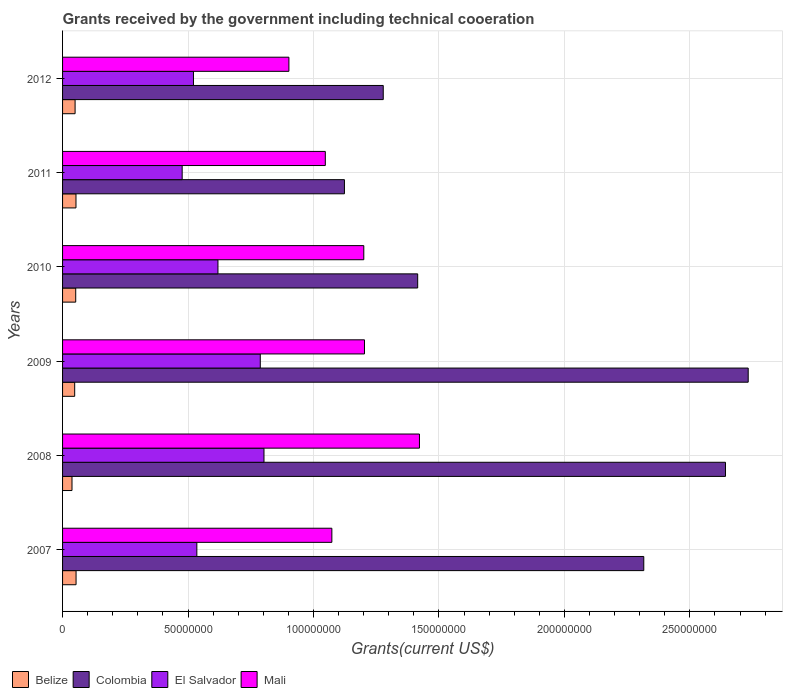How many groups of bars are there?
Your answer should be very brief. 6. Are the number of bars on each tick of the Y-axis equal?
Your answer should be compact. Yes. How many bars are there on the 3rd tick from the top?
Your answer should be very brief. 4. What is the label of the 6th group of bars from the top?
Ensure brevity in your answer.  2007. In how many cases, is the number of bars for a given year not equal to the number of legend labels?
Your answer should be compact. 0. What is the total grants received by the government in Mali in 2010?
Your answer should be very brief. 1.20e+08. Across all years, what is the maximum total grants received by the government in Mali?
Keep it short and to the point. 1.42e+08. Across all years, what is the minimum total grants received by the government in Colombia?
Make the answer very short. 1.12e+08. In which year was the total grants received by the government in Colombia minimum?
Keep it short and to the point. 2011. What is the total total grants received by the government in Mali in the graph?
Give a very brief answer. 6.85e+08. What is the difference between the total grants received by the government in Belize in 2008 and that in 2010?
Your answer should be very brief. -1.48e+06. What is the difference between the total grants received by the government in Mali in 2011 and the total grants received by the government in Colombia in 2007?
Provide a short and direct response. -1.27e+08. What is the average total grants received by the government in Colombia per year?
Provide a short and direct response. 1.92e+08. In the year 2007, what is the difference between the total grants received by the government in El Salvador and total grants received by the government in Colombia?
Give a very brief answer. -1.78e+08. What is the ratio of the total grants received by the government in El Salvador in 2008 to that in 2011?
Make the answer very short. 1.68. Is the difference between the total grants received by the government in El Salvador in 2009 and 2010 greater than the difference between the total grants received by the government in Colombia in 2009 and 2010?
Ensure brevity in your answer.  No. What is the difference between the highest and the lowest total grants received by the government in El Salvador?
Provide a short and direct response. 3.26e+07. Is it the case that in every year, the sum of the total grants received by the government in Belize and total grants received by the government in Mali is greater than the sum of total grants received by the government in Colombia and total grants received by the government in El Salvador?
Make the answer very short. No. What does the 4th bar from the top in 2010 represents?
Offer a very short reply. Belize. What does the 2nd bar from the bottom in 2008 represents?
Give a very brief answer. Colombia. How many bars are there?
Offer a terse response. 24. What is the difference between two consecutive major ticks on the X-axis?
Provide a succinct answer. 5.00e+07. Where does the legend appear in the graph?
Provide a succinct answer. Bottom left. What is the title of the graph?
Provide a short and direct response. Grants received by the government including technical cooeration. What is the label or title of the X-axis?
Provide a succinct answer. Grants(current US$). What is the label or title of the Y-axis?
Your answer should be very brief. Years. What is the Grants(current US$) of Belize in 2007?
Provide a succinct answer. 5.38e+06. What is the Grants(current US$) in Colombia in 2007?
Your response must be concise. 2.32e+08. What is the Grants(current US$) in El Salvador in 2007?
Make the answer very short. 5.35e+07. What is the Grants(current US$) of Mali in 2007?
Make the answer very short. 1.07e+08. What is the Grants(current US$) in Belize in 2008?
Give a very brief answer. 3.76e+06. What is the Grants(current US$) in Colombia in 2008?
Keep it short and to the point. 2.64e+08. What is the Grants(current US$) of El Salvador in 2008?
Make the answer very short. 8.03e+07. What is the Grants(current US$) in Mali in 2008?
Provide a succinct answer. 1.42e+08. What is the Grants(current US$) in Belize in 2009?
Provide a succinct answer. 4.83e+06. What is the Grants(current US$) in Colombia in 2009?
Provide a succinct answer. 2.73e+08. What is the Grants(current US$) in El Salvador in 2009?
Ensure brevity in your answer.  7.88e+07. What is the Grants(current US$) of Mali in 2009?
Offer a very short reply. 1.20e+08. What is the Grants(current US$) of Belize in 2010?
Make the answer very short. 5.24e+06. What is the Grants(current US$) in Colombia in 2010?
Provide a succinct answer. 1.42e+08. What is the Grants(current US$) of El Salvador in 2010?
Your answer should be compact. 6.19e+07. What is the Grants(current US$) in Mali in 2010?
Provide a short and direct response. 1.20e+08. What is the Grants(current US$) of Belize in 2011?
Give a very brief answer. 5.35e+06. What is the Grants(current US$) of Colombia in 2011?
Make the answer very short. 1.12e+08. What is the Grants(current US$) of El Salvador in 2011?
Your response must be concise. 4.77e+07. What is the Grants(current US$) in Mali in 2011?
Offer a terse response. 1.05e+08. What is the Grants(current US$) in Belize in 2012?
Give a very brief answer. 4.99e+06. What is the Grants(current US$) of Colombia in 2012?
Provide a short and direct response. 1.28e+08. What is the Grants(current US$) of El Salvador in 2012?
Your answer should be very brief. 5.22e+07. What is the Grants(current US$) in Mali in 2012?
Provide a succinct answer. 9.02e+07. Across all years, what is the maximum Grants(current US$) of Belize?
Offer a very short reply. 5.38e+06. Across all years, what is the maximum Grants(current US$) of Colombia?
Make the answer very short. 2.73e+08. Across all years, what is the maximum Grants(current US$) of El Salvador?
Your response must be concise. 8.03e+07. Across all years, what is the maximum Grants(current US$) of Mali?
Your answer should be compact. 1.42e+08. Across all years, what is the minimum Grants(current US$) in Belize?
Offer a terse response. 3.76e+06. Across all years, what is the minimum Grants(current US$) of Colombia?
Give a very brief answer. 1.12e+08. Across all years, what is the minimum Grants(current US$) in El Salvador?
Offer a very short reply. 4.77e+07. Across all years, what is the minimum Grants(current US$) in Mali?
Provide a succinct answer. 9.02e+07. What is the total Grants(current US$) in Belize in the graph?
Give a very brief answer. 2.96e+07. What is the total Grants(current US$) of Colombia in the graph?
Provide a succinct answer. 1.15e+09. What is the total Grants(current US$) in El Salvador in the graph?
Your answer should be compact. 3.74e+08. What is the total Grants(current US$) of Mali in the graph?
Provide a succinct answer. 6.85e+08. What is the difference between the Grants(current US$) in Belize in 2007 and that in 2008?
Give a very brief answer. 1.62e+06. What is the difference between the Grants(current US$) of Colombia in 2007 and that in 2008?
Offer a terse response. -3.26e+07. What is the difference between the Grants(current US$) in El Salvador in 2007 and that in 2008?
Offer a very short reply. -2.68e+07. What is the difference between the Grants(current US$) of Mali in 2007 and that in 2008?
Offer a terse response. -3.49e+07. What is the difference between the Grants(current US$) in Belize in 2007 and that in 2009?
Your answer should be very brief. 5.50e+05. What is the difference between the Grants(current US$) in Colombia in 2007 and that in 2009?
Your answer should be compact. -4.16e+07. What is the difference between the Grants(current US$) of El Salvador in 2007 and that in 2009?
Your response must be concise. -2.53e+07. What is the difference between the Grants(current US$) in Mali in 2007 and that in 2009?
Keep it short and to the point. -1.30e+07. What is the difference between the Grants(current US$) in Belize in 2007 and that in 2010?
Offer a terse response. 1.40e+05. What is the difference between the Grants(current US$) of Colombia in 2007 and that in 2010?
Offer a very short reply. 9.01e+07. What is the difference between the Grants(current US$) in El Salvador in 2007 and that in 2010?
Your answer should be very brief. -8.41e+06. What is the difference between the Grants(current US$) in Mali in 2007 and that in 2010?
Offer a terse response. -1.27e+07. What is the difference between the Grants(current US$) of Belize in 2007 and that in 2011?
Offer a terse response. 3.00e+04. What is the difference between the Grants(current US$) in Colombia in 2007 and that in 2011?
Your answer should be compact. 1.19e+08. What is the difference between the Grants(current US$) in El Salvador in 2007 and that in 2011?
Your answer should be compact. 5.85e+06. What is the difference between the Grants(current US$) in Mali in 2007 and that in 2011?
Keep it short and to the point. 2.61e+06. What is the difference between the Grants(current US$) of Belize in 2007 and that in 2012?
Provide a succinct answer. 3.90e+05. What is the difference between the Grants(current US$) in Colombia in 2007 and that in 2012?
Offer a very short reply. 1.04e+08. What is the difference between the Grants(current US$) of El Salvador in 2007 and that in 2012?
Provide a short and direct response. 1.35e+06. What is the difference between the Grants(current US$) in Mali in 2007 and that in 2012?
Your response must be concise. 1.71e+07. What is the difference between the Grants(current US$) in Belize in 2008 and that in 2009?
Offer a terse response. -1.07e+06. What is the difference between the Grants(current US$) of Colombia in 2008 and that in 2009?
Ensure brevity in your answer.  -9.06e+06. What is the difference between the Grants(current US$) of El Salvador in 2008 and that in 2009?
Offer a terse response. 1.48e+06. What is the difference between the Grants(current US$) in Mali in 2008 and that in 2009?
Your answer should be compact. 2.19e+07. What is the difference between the Grants(current US$) of Belize in 2008 and that in 2010?
Your answer should be very brief. -1.48e+06. What is the difference between the Grants(current US$) in Colombia in 2008 and that in 2010?
Your answer should be very brief. 1.23e+08. What is the difference between the Grants(current US$) of El Salvador in 2008 and that in 2010?
Make the answer very short. 1.84e+07. What is the difference between the Grants(current US$) in Mali in 2008 and that in 2010?
Ensure brevity in your answer.  2.22e+07. What is the difference between the Grants(current US$) in Belize in 2008 and that in 2011?
Offer a terse response. -1.59e+06. What is the difference between the Grants(current US$) in Colombia in 2008 and that in 2011?
Your response must be concise. 1.52e+08. What is the difference between the Grants(current US$) of El Salvador in 2008 and that in 2011?
Make the answer very short. 3.26e+07. What is the difference between the Grants(current US$) of Mali in 2008 and that in 2011?
Give a very brief answer. 3.75e+07. What is the difference between the Grants(current US$) in Belize in 2008 and that in 2012?
Offer a terse response. -1.23e+06. What is the difference between the Grants(current US$) of Colombia in 2008 and that in 2012?
Your answer should be compact. 1.36e+08. What is the difference between the Grants(current US$) in El Salvador in 2008 and that in 2012?
Your answer should be very brief. 2.81e+07. What is the difference between the Grants(current US$) of Mali in 2008 and that in 2012?
Keep it short and to the point. 5.20e+07. What is the difference between the Grants(current US$) in Belize in 2009 and that in 2010?
Keep it short and to the point. -4.10e+05. What is the difference between the Grants(current US$) of Colombia in 2009 and that in 2010?
Keep it short and to the point. 1.32e+08. What is the difference between the Grants(current US$) of El Salvador in 2009 and that in 2010?
Provide a short and direct response. 1.69e+07. What is the difference between the Grants(current US$) of Mali in 2009 and that in 2010?
Provide a short and direct response. 2.70e+05. What is the difference between the Grants(current US$) of Belize in 2009 and that in 2011?
Provide a short and direct response. -5.20e+05. What is the difference between the Grants(current US$) in Colombia in 2009 and that in 2011?
Provide a succinct answer. 1.61e+08. What is the difference between the Grants(current US$) of El Salvador in 2009 and that in 2011?
Offer a terse response. 3.11e+07. What is the difference between the Grants(current US$) of Mali in 2009 and that in 2011?
Make the answer very short. 1.56e+07. What is the difference between the Grants(current US$) of Colombia in 2009 and that in 2012?
Keep it short and to the point. 1.45e+08. What is the difference between the Grants(current US$) of El Salvador in 2009 and that in 2012?
Ensure brevity in your answer.  2.66e+07. What is the difference between the Grants(current US$) of Mali in 2009 and that in 2012?
Your answer should be compact. 3.01e+07. What is the difference between the Grants(current US$) of Belize in 2010 and that in 2011?
Provide a succinct answer. -1.10e+05. What is the difference between the Grants(current US$) of Colombia in 2010 and that in 2011?
Make the answer very short. 2.92e+07. What is the difference between the Grants(current US$) in El Salvador in 2010 and that in 2011?
Provide a succinct answer. 1.43e+07. What is the difference between the Grants(current US$) in Mali in 2010 and that in 2011?
Keep it short and to the point. 1.53e+07. What is the difference between the Grants(current US$) in Colombia in 2010 and that in 2012?
Provide a succinct answer. 1.37e+07. What is the difference between the Grants(current US$) in El Salvador in 2010 and that in 2012?
Offer a very short reply. 9.76e+06. What is the difference between the Grants(current US$) of Mali in 2010 and that in 2012?
Your response must be concise. 2.98e+07. What is the difference between the Grants(current US$) in Colombia in 2011 and that in 2012?
Make the answer very short. -1.55e+07. What is the difference between the Grants(current US$) of El Salvador in 2011 and that in 2012?
Offer a very short reply. -4.50e+06. What is the difference between the Grants(current US$) of Mali in 2011 and that in 2012?
Provide a short and direct response. 1.45e+07. What is the difference between the Grants(current US$) of Belize in 2007 and the Grants(current US$) of Colombia in 2008?
Your answer should be compact. -2.59e+08. What is the difference between the Grants(current US$) in Belize in 2007 and the Grants(current US$) in El Salvador in 2008?
Your answer should be very brief. -7.49e+07. What is the difference between the Grants(current US$) of Belize in 2007 and the Grants(current US$) of Mali in 2008?
Your response must be concise. -1.37e+08. What is the difference between the Grants(current US$) of Colombia in 2007 and the Grants(current US$) of El Salvador in 2008?
Give a very brief answer. 1.51e+08. What is the difference between the Grants(current US$) of Colombia in 2007 and the Grants(current US$) of Mali in 2008?
Your response must be concise. 8.94e+07. What is the difference between the Grants(current US$) of El Salvador in 2007 and the Grants(current US$) of Mali in 2008?
Your answer should be compact. -8.87e+07. What is the difference between the Grants(current US$) of Belize in 2007 and the Grants(current US$) of Colombia in 2009?
Offer a very short reply. -2.68e+08. What is the difference between the Grants(current US$) in Belize in 2007 and the Grants(current US$) in El Salvador in 2009?
Give a very brief answer. -7.34e+07. What is the difference between the Grants(current US$) of Belize in 2007 and the Grants(current US$) of Mali in 2009?
Your response must be concise. -1.15e+08. What is the difference between the Grants(current US$) of Colombia in 2007 and the Grants(current US$) of El Salvador in 2009?
Your answer should be very brief. 1.53e+08. What is the difference between the Grants(current US$) of Colombia in 2007 and the Grants(current US$) of Mali in 2009?
Give a very brief answer. 1.11e+08. What is the difference between the Grants(current US$) of El Salvador in 2007 and the Grants(current US$) of Mali in 2009?
Ensure brevity in your answer.  -6.68e+07. What is the difference between the Grants(current US$) of Belize in 2007 and the Grants(current US$) of Colombia in 2010?
Your answer should be compact. -1.36e+08. What is the difference between the Grants(current US$) in Belize in 2007 and the Grants(current US$) in El Salvador in 2010?
Offer a very short reply. -5.66e+07. What is the difference between the Grants(current US$) in Belize in 2007 and the Grants(current US$) in Mali in 2010?
Your response must be concise. -1.15e+08. What is the difference between the Grants(current US$) of Colombia in 2007 and the Grants(current US$) of El Salvador in 2010?
Give a very brief answer. 1.70e+08. What is the difference between the Grants(current US$) in Colombia in 2007 and the Grants(current US$) in Mali in 2010?
Your answer should be very brief. 1.12e+08. What is the difference between the Grants(current US$) in El Salvador in 2007 and the Grants(current US$) in Mali in 2010?
Make the answer very short. -6.65e+07. What is the difference between the Grants(current US$) of Belize in 2007 and the Grants(current US$) of Colombia in 2011?
Offer a very short reply. -1.07e+08. What is the difference between the Grants(current US$) in Belize in 2007 and the Grants(current US$) in El Salvador in 2011?
Give a very brief answer. -4.23e+07. What is the difference between the Grants(current US$) of Belize in 2007 and the Grants(current US$) of Mali in 2011?
Give a very brief answer. -9.93e+07. What is the difference between the Grants(current US$) in Colombia in 2007 and the Grants(current US$) in El Salvador in 2011?
Your answer should be compact. 1.84e+08. What is the difference between the Grants(current US$) of Colombia in 2007 and the Grants(current US$) of Mali in 2011?
Offer a terse response. 1.27e+08. What is the difference between the Grants(current US$) of El Salvador in 2007 and the Grants(current US$) of Mali in 2011?
Your answer should be very brief. -5.12e+07. What is the difference between the Grants(current US$) of Belize in 2007 and the Grants(current US$) of Colombia in 2012?
Your answer should be very brief. -1.22e+08. What is the difference between the Grants(current US$) in Belize in 2007 and the Grants(current US$) in El Salvador in 2012?
Make the answer very short. -4.68e+07. What is the difference between the Grants(current US$) of Belize in 2007 and the Grants(current US$) of Mali in 2012?
Keep it short and to the point. -8.48e+07. What is the difference between the Grants(current US$) of Colombia in 2007 and the Grants(current US$) of El Salvador in 2012?
Make the answer very short. 1.79e+08. What is the difference between the Grants(current US$) of Colombia in 2007 and the Grants(current US$) of Mali in 2012?
Ensure brevity in your answer.  1.41e+08. What is the difference between the Grants(current US$) of El Salvador in 2007 and the Grants(current US$) of Mali in 2012?
Give a very brief answer. -3.67e+07. What is the difference between the Grants(current US$) of Belize in 2008 and the Grants(current US$) of Colombia in 2009?
Provide a succinct answer. -2.70e+08. What is the difference between the Grants(current US$) of Belize in 2008 and the Grants(current US$) of El Salvador in 2009?
Keep it short and to the point. -7.50e+07. What is the difference between the Grants(current US$) in Belize in 2008 and the Grants(current US$) in Mali in 2009?
Make the answer very short. -1.17e+08. What is the difference between the Grants(current US$) of Colombia in 2008 and the Grants(current US$) of El Salvador in 2009?
Your answer should be very brief. 1.85e+08. What is the difference between the Grants(current US$) in Colombia in 2008 and the Grants(current US$) in Mali in 2009?
Offer a very short reply. 1.44e+08. What is the difference between the Grants(current US$) of El Salvador in 2008 and the Grants(current US$) of Mali in 2009?
Offer a very short reply. -4.00e+07. What is the difference between the Grants(current US$) of Belize in 2008 and the Grants(current US$) of Colombia in 2010?
Your answer should be compact. -1.38e+08. What is the difference between the Grants(current US$) of Belize in 2008 and the Grants(current US$) of El Salvador in 2010?
Provide a short and direct response. -5.82e+07. What is the difference between the Grants(current US$) of Belize in 2008 and the Grants(current US$) of Mali in 2010?
Keep it short and to the point. -1.16e+08. What is the difference between the Grants(current US$) in Colombia in 2008 and the Grants(current US$) in El Salvador in 2010?
Ensure brevity in your answer.  2.02e+08. What is the difference between the Grants(current US$) of Colombia in 2008 and the Grants(current US$) of Mali in 2010?
Make the answer very short. 1.44e+08. What is the difference between the Grants(current US$) in El Salvador in 2008 and the Grants(current US$) in Mali in 2010?
Provide a succinct answer. -3.98e+07. What is the difference between the Grants(current US$) in Belize in 2008 and the Grants(current US$) in Colombia in 2011?
Offer a terse response. -1.09e+08. What is the difference between the Grants(current US$) of Belize in 2008 and the Grants(current US$) of El Salvador in 2011?
Give a very brief answer. -4.39e+07. What is the difference between the Grants(current US$) of Belize in 2008 and the Grants(current US$) of Mali in 2011?
Your answer should be compact. -1.01e+08. What is the difference between the Grants(current US$) in Colombia in 2008 and the Grants(current US$) in El Salvador in 2011?
Ensure brevity in your answer.  2.17e+08. What is the difference between the Grants(current US$) in Colombia in 2008 and the Grants(current US$) in Mali in 2011?
Offer a very short reply. 1.59e+08. What is the difference between the Grants(current US$) in El Salvador in 2008 and the Grants(current US$) in Mali in 2011?
Give a very brief answer. -2.44e+07. What is the difference between the Grants(current US$) of Belize in 2008 and the Grants(current US$) of Colombia in 2012?
Your response must be concise. -1.24e+08. What is the difference between the Grants(current US$) in Belize in 2008 and the Grants(current US$) in El Salvador in 2012?
Make the answer very short. -4.84e+07. What is the difference between the Grants(current US$) of Belize in 2008 and the Grants(current US$) of Mali in 2012?
Make the answer very short. -8.64e+07. What is the difference between the Grants(current US$) in Colombia in 2008 and the Grants(current US$) in El Salvador in 2012?
Offer a very short reply. 2.12e+08. What is the difference between the Grants(current US$) of Colombia in 2008 and the Grants(current US$) of Mali in 2012?
Provide a short and direct response. 1.74e+08. What is the difference between the Grants(current US$) of El Salvador in 2008 and the Grants(current US$) of Mali in 2012?
Your answer should be compact. -9.93e+06. What is the difference between the Grants(current US$) in Belize in 2009 and the Grants(current US$) in Colombia in 2010?
Your response must be concise. -1.37e+08. What is the difference between the Grants(current US$) of Belize in 2009 and the Grants(current US$) of El Salvador in 2010?
Provide a succinct answer. -5.71e+07. What is the difference between the Grants(current US$) in Belize in 2009 and the Grants(current US$) in Mali in 2010?
Ensure brevity in your answer.  -1.15e+08. What is the difference between the Grants(current US$) in Colombia in 2009 and the Grants(current US$) in El Salvador in 2010?
Keep it short and to the point. 2.11e+08. What is the difference between the Grants(current US$) of Colombia in 2009 and the Grants(current US$) of Mali in 2010?
Ensure brevity in your answer.  1.53e+08. What is the difference between the Grants(current US$) of El Salvador in 2009 and the Grants(current US$) of Mali in 2010?
Provide a short and direct response. -4.13e+07. What is the difference between the Grants(current US$) of Belize in 2009 and the Grants(current US$) of Colombia in 2011?
Offer a terse response. -1.08e+08. What is the difference between the Grants(current US$) in Belize in 2009 and the Grants(current US$) in El Salvador in 2011?
Keep it short and to the point. -4.28e+07. What is the difference between the Grants(current US$) in Belize in 2009 and the Grants(current US$) in Mali in 2011?
Offer a terse response. -9.99e+07. What is the difference between the Grants(current US$) of Colombia in 2009 and the Grants(current US$) of El Salvador in 2011?
Your response must be concise. 2.26e+08. What is the difference between the Grants(current US$) of Colombia in 2009 and the Grants(current US$) of Mali in 2011?
Your answer should be very brief. 1.69e+08. What is the difference between the Grants(current US$) in El Salvador in 2009 and the Grants(current US$) in Mali in 2011?
Give a very brief answer. -2.59e+07. What is the difference between the Grants(current US$) in Belize in 2009 and the Grants(current US$) in Colombia in 2012?
Give a very brief answer. -1.23e+08. What is the difference between the Grants(current US$) of Belize in 2009 and the Grants(current US$) of El Salvador in 2012?
Provide a short and direct response. -4.73e+07. What is the difference between the Grants(current US$) in Belize in 2009 and the Grants(current US$) in Mali in 2012?
Give a very brief answer. -8.54e+07. What is the difference between the Grants(current US$) of Colombia in 2009 and the Grants(current US$) of El Salvador in 2012?
Your answer should be compact. 2.21e+08. What is the difference between the Grants(current US$) in Colombia in 2009 and the Grants(current US$) in Mali in 2012?
Offer a terse response. 1.83e+08. What is the difference between the Grants(current US$) of El Salvador in 2009 and the Grants(current US$) of Mali in 2012?
Your answer should be very brief. -1.14e+07. What is the difference between the Grants(current US$) of Belize in 2010 and the Grants(current US$) of Colombia in 2011?
Offer a terse response. -1.07e+08. What is the difference between the Grants(current US$) of Belize in 2010 and the Grants(current US$) of El Salvador in 2011?
Keep it short and to the point. -4.24e+07. What is the difference between the Grants(current US$) in Belize in 2010 and the Grants(current US$) in Mali in 2011?
Provide a succinct answer. -9.95e+07. What is the difference between the Grants(current US$) in Colombia in 2010 and the Grants(current US$) in El Salvador in 2011?
Give a very brief answer. 9.39e+07. What is the difference between the Grants(current US$) of Colombia in 2010 and the Grants(current US$) of Mali in 2011?
Keep it short and to the point. 3.68e+07. What is the difference between the Grants(current US$) in El Salvador in 2010 and the Grants(current US$) in Mali in 2011?
Provide a succinct answer. -4.28e+07. What is the difference between the Grants(current US$) of Belize in 2010 and the Grants(current US$) of Colombia in 2012?
Offer a terse response. -1.23e+08. What is the difference between the Grants(current US$) of Belize in 2010 and the Grants(current US$) of El Salvador in 2012?
Offer a terse response. -4.69e+07. What is the difference between the Grants(current US$) of Belize in 2010 and the Grants(current US$) of Mali in 2012?
Offer a very short reply. -8.50e+07. What is the difference between the Grants(current US$) of Colombia in 2010 and the Grants(current US$) of El Salvador in 2012?
Provide a succinct answer. 8.94e+07. What is the difference between the Grants(current US$) of Colombia in 2010 and the Grants(current US$) of Mali in 2012?
Your response must be concise. 5.13e+07. What is the difference between the Grants(current US$) of El Salvador in 2010 and the Grants(current US$) of Mali in 2012?
Offer a very short reply. -2.83e+07. What is the difference between the Grants(current US$) in Belize in 2011 and the Grants(current US$) in Colombia in 2012?
Provide a short and direct response. -1.22e+08. What is the difference between the Grants(current US$) in Belize in 2011 and the Grants(current US$) in El Salvador in 2012?
Your answer should be very brief. -4.68e+07. What is the difference between the Grants(current US$) of Belize in 2011 and the Grants(current US$) of Mali in 2012?
Keep it short and to the point. -8.49e+07. What is the difference between the Grants(current US$) in Colombia in 2011 and the Grants(current US$) in El Salvador in 2012?
Keep it short and to the point. 6.02e+07. What is the difference between the Grants(current US$) in Colombia in 2011 and the Grants(current US$) in Mali in 2012?
Your answer should be compact. 2.21e+07. What is the difference between the Grants(current US$) in El Salvador in 2011 and the Grants(current US$) in Mali in 2012?
Offer a very short reply. -4.25e+07. What is the average Grants(current US$) of Belize per year?
Offer a terse response. 4.92e+06. What is the average Grants(current US$) in Colombia per year?
Ensure brevity in your answer.  1.92e+08. What is the average Grants(current US$) in El Salvador per year?
Provide a short and direct response. 6.24e+07. What is the average Grants(current US$) in Mali per year?
Provide a succinct answer. 1.14e+08. In the year 2007, what is the difference between the Grants(current US$) in Belize and Grants(current US$) in Colombia?
Provide a short and direct response. -2.26e+08. In the year 2007, what is the difference between the Grants(current US$) in Belize and Grants(current US$) in El Salvador?
Your answer should be compact. -4.81e+07. In the year 2007, what is the difference between the Grants(current US$) of Belize and Grants(current US$) of Mali?
Keep it short and to the point. -1.02e+08. In the year 2007, what is the difference between the Grants(current US$) of Colombia and Grants(current US$) of El Salvador?
Give a very brief answer. 1.78e+08. In the year 2007, what is the difference between the Grants(current US$) in Colombia and Grants(current US$) in Mali?
Make the answer very short. 1.24e+08. In the year 2007, what is the difference between the Grants(current US$) of El Salvador and Grants(current US$) of Mali?
Your answer should be very brief. -5.38e+07. In the year 2008, what is the difference between the Grants(current US$) in Belize and Grants(current US$) in Colombia?
Keep it short and to the point. -2.60e+08. In the year 2008, what is the difference between the Grants(current US$) in Belize and Grants(current US$) in El Salvador?
Offer a very short reply. -7.65e+07. In the year 2008, what is the difference between the Grants(current US$) in Belize and Grants(current US$) in Mali?
Offer a terse response. -1.38e+08. In the year 2008, what is the difference between the Grants(current US$) in Colombia and Grants(current US$) in El Salvador?
Your answer should be compact. 1.84e+08. In the year 2008, what is the difference between the Grants(current US$) of Colombia and Grants(current US$) of Mali?
Your response must be concise. 1.22e+08. In the year 2008, what is the difference between the Grants(current US$) in El Salvador and Grants(current US$) in Mali?
Your response must be concise. -6.20e+07. In the year 2009, what is the difference between the Grants(current US$) in Belize and Grants(current US$) in Colombia?
Give a very brief answer. -2.68e+08. In the year 2009, what is the difference between the Grants(current US$) in Belize and Grants(current US$) in El Salvador?
Offer a terse response. -7.40e+07. In the year 2009, what is the difference between the Grants(current US$) of Belize and Grants(current US$) of Mali?
Your response must be concise. -1.16e+08. In the year 2009, what is the difference between the Grants(current US$) in Colombia and Grants(current US$) in El Salvador?
Ensure brevity in your answer.  1.94e+08. In the year 2009, what is the difference between the Grants(current US$) of Colombia and Grants(current US$) of Mali?
Offer a terse response. 1.53e+08. In the year 2009, what is the difference between the Grants(current US$) in El Salvador and Grants(current US$) in Mali?
Provide a succinct answer. -4.15e+07. In the year 2010, what is the difference between the Grants(current US$) in Belize and Grants(current US$) in Colombia?
Give a very brief answer. -1.36e+08. In the year 2010, what is the difference between the Grants(current US$) in Belize and Grants(current US$) in El Salvador?
Offer a very short reply. -5.67e+07. In the year 2010, what is the difference between the Grants(current US$) of Belize and Grants(current US$) of Mali?
Your answer should be compact. -1.15e+08. In the year 2010, what is the difference between the Grants(current US$) of Colombia and Grants(current US$) of El Salvador?
Your response must be concise. 7.96e+07. In the year 2010, what is the difference between the Grants(current US$) of Colombia and Grants(current US$) of Mali?
Provide a short and direct response. 2.15e+07. In the year 2010, what is the difference between the Grants(current US$) of El Salvador and Grants(current US$) of Mali?
Offer a very short reply. -5.81e+07. In the year 2011, what is the difference between the Grants(current US$) of Belize and Grants(current US$) of Colombia?
Make the answer very short. -1.07e+08. In the year 2011, what is the difference between the Grants(current US$) of Belize and Grants(current US$) of El Salvador?
Give a very brief answer. -4.23e+07. In the year 2011, what is the difference between the Grants(current US$) in Belize and Grants(current US$) in Mali?
Your response must be concise. -9.94e+07. In the year 2011, what is the difference between the Grants(current US$) in Colombia and Grants(current US$) in El Salvador?
Your answer should be very brief. 6.47e+07. In the year 2011, what is the difference between the Grants(current US$) of Colombia and Grants(current US$) of Mali?
Give a very brief answer. 7.62e+06. In the year 2011, what is the difference between the Grants(current US$) of El Salvador and Grants(current US$) of Mali?
Ensure brevity in your answer.  -5.70e+07. In the year 2012, what is the difference between the Grants(current US$) of Belize and Grants(current US$) of Colombia?
Keep it short and to the point. -1.23e+08. In the year 2012, what is the difference between the Grants(current US$) of Belize and Grants(current US$) of El Salvador?
Your answer should be compact. -4.72e+07. In the year 2012, what is the difference between the Grants(current US$) of Belize and Grants(current US$) of Mali?
Ensure brevity in your answer.  -8.52e+07. In the year 2012, what is the difference between the Grants(current US$) in Colombia and Grants(current US$) in El Salvador?
Ensure brevity in your answer.  7.56e+07. In the year 2012, what is the difference between the Grants(current US$) of Colombia and Grants(current US$) of Mali?
Offer a terse response. 3.76e+07. In the year 2012, what is the difference between the Grants(current US$) in El Salvador and Grants(current US$) in Mali?
Ensure brevity in your answer.  -3.80e+07. What is the ratio of the Grants(current US$) of Belize in 2007 to that in 2008?
Keep it short and to the point. 1.43. What is the ratio of the Grants(current US$) of Colombia in 2007 to that in 2008?
Provide a succinct answer. 0.88. What is the ratio of the Grants(current US$) of Mali in 2007 to that in 2008?
Offer a terse response. 0.75. What is the ratio of the Grants(current US$) in Belize in 2007 to that in 2009?
Your response must be concise. 1.11. What is the ratio of the Grants(current US$) of Colombia in 2007 to that in 2009?
Offer a very short reply. 0.85. What is the ratio of the Grants(current US$) of El Salvador in 2007 to that in 2009?
Make the answer very short. 0.68. What is the ratio of the Grants(current US$) in Mali in 2007 to that in 2009?
Offer a terse response. 0.89. What is the ratio of the Grants(current US$) of Belize in 2007 to that in 2010?
Your answer should be very brief. 1.03. What is the ratio of the Grants(current US$) of Colombia in 2007 to that in 2010?
Offer a very short reply. 1.64. What is the ratio of the Grants(current US$) in El Salvador in 2007 to that in 2010?
Your answer should be very brief. 0.86. What is the ratio of the Grants(current US$) in Mali in 2007 to that in 2010?
Make the answer very short. 0.89. What is the ratio of the Grants(current US$) of Belize in 2007 to that in 2011?
Provide a short and direct response. 1.01. What is the ratio of the Grants(current US$) of Colombia in 2007 to that in 2011?
Offer a terse response. 2.06. What is the ratio of the Grants(current US$) in El Salvador in 2007 to that in 2011?
Provide a succinct answer. 1.12. What is the ratio of the Grants(current US$) of Mali in 2007 to that in 2011?
Provide a succinct answer. 1.02. What is the ratio of the Grants(current US$) of Belize in 2007 to that in 2012?
Provide a short and direct response. 1.08. What is the ratio of the Grants(current US$) of Colombia in 2007 to that in 2012?
Keep it short and to the point. 1.81. What is the ratio of the Grants(current US$) in El Salvador in 2007 to that in 2012?
Provide a succinct answer. 1.03. What is the ratio of the Grants(current US$) in Mali in 2007 to that in 2012?
Your answer should be compact. 1.19. What is the ratio of the Grants(current US$) in Belize in 2008 to that in 2009?
Provide a short and direct response. 0.78. What is the ratio of the Grants(current US$) in Colombia in 2008 to that in 2009?
Make the answer very short. 0.97. What is the ratio of the Grants(current US$) in El Salvador in 2008 to that in 2009?
Offer a terse response. 1.02. What is the ratio of the Grants(current US$) in Mali in 2008 to that in 2009?
Keep it short and to the point. 1.18. What is the ratio of the Grants(current US$) of Belize in 2008 to that in 2010?
Keep it short and to the point. 0.72. What is the ratio of the Grants(current US$) of Colombia in 2008 to that in 2010?
Keep it short and to the point. 1.87. What is the ratio of the Grants(current US$) in El Salvador in 2008 to that in 2010?
Offer a terse response. 1.3. What is the ratio of the Grants(current US$) of Mali in 2008 to that in 2010?
Your response must be concise. 1.18. What is the ratio of the Grants(current US$) of Belize in 2008 to that in 2011?
Give a very brief answer. 0.7. What is the ratio of the Grants(current US$) in Colombia in 2008 to that in 2011?
Ensure brevity in your answer.  2.35. What is the ratio of the Grants(current US$) of El Salvador in 2008 to that in 2011?
Offer a terse response. 1.68. What is the ratio of the Grants(current US$) of Mali in 2008 to that in 2011?
Your response must be concise. 1.36. What is the ratio of the Grants(current US$) of Belize in 2008 to that in 2012?
Make the answer very short. 0.75. What is the ratio of the Grants(current US$) in Colombia in 2008 to that in 2012?
Your answer should be very brief. 2.07. What is the ratio of the Grants(current US$) in El Salvador in 2008 to that in 2012?
Make the answer very short. 1.54. What is the ratio of the Grants(current US$) of Mali in 2008 to that in 2012?
Provide a short and direct response. 1.58. What is the ratio of the Grants(current US$) in Belize in 2009 to that in 2010?
Make the answer very short. 0.92. What is the ratio of the Grants(current US$) of Colombia in 2009 to that in 2010?
Give a very brief answer. 1.93. What is the ratio of the Grants(current US$) in El Salvador in 2009 to that in 2010?
Provide a succinct answer. 1.27. What is the ratio of the Grants(current US$) of Belize in 2009 to that in 2011?
Your answer should be compact. 0.9. What is the ratio of the Grants(current US$) of Colombia in 2009 to that in 2011?
Your answer should be compact. 2.43. What is the ratio of the Grants(current US$) in El Salvador in 2009 to that in 2011?
Provide a succinct answer. 1.65. What is the ratio of the Grants(current US$) of Mali in 2009 to that in 2011?
Offer a very short reply. 1.15. What is the ratio of the Grants(current US$) of Belize in 2009 to that in 2012?
Ensure brevity in your answer.  0.97. What is the ratio of the Grants(current US$) of Colombia in 2009 to that in 2012?
Provide a succinct answer. 2.14. What is the ratio of the Grants(current US$) in El Salvador in 2009 to that in 2012?
Your response must be concise. 1.51. What is the ratio of the Grants(current US$) in Mali in 2009 to that in 2012?
Keep it short and to the point. 1.33. What is the ratio of the Grants(current US$) in Belize in 2010 to that in 2011?
Your answer should be compact. 0.98. What is the ratio of the Grants(current US$) in Colombia in 2010 to that in 2011?
Make the answer very short. 1.26. What is the ratio of the Grants(current US$) of El Salvador in 2010 to that in 2011?
Your answer should be compact. 1.3. What is the ratio of the Grants(current US$) of Mali in 2010 to that in 2011?
Your answer should be very brief. 1.15. What is the ratio of the Grants(current US$) of Belize in 2010 to that in 2012?
Your answer should be very brief. 1.05. What is the ratio of the Grants(current US$) of Colombia in 2010 to that in 2012?
Provide a succinct answer. 1.11. What is the ratio of the Grants(current US$) in El Salvador in 2010 to that in 2012?
Provide a succinct answer. 1.19. What is the ratio of the Grants(current US$) in Mali in 2010 to that in 2012?
Your answer should be compact. 1.33. What is the ratio of the Grants(current US$) in Belize in 2011 to that in 2012?
Make the answer very short. 1.07. What is the ratio of the Grants(current US$) in Colombia in 2011 to that in 2012?
Keep it short and to the point. 0.88. What is the ratio of the Grants(current US$) in El Salvador in 2011 to that in 2012?
Give a very brief answer. 0.91. What is the ratio of the Grants(current US$) of Mali in 2011 to that in 2012?
Provide a short and direct response. 1.16. What is the difference between the highest and the second highest Grants(current US$) of Belize?
Make the answer very short. 3.00e+04. What is the difference between the highest and the second highest Grants(current US$) of Colombia?
Offer a terse response. 9.06e+06. What is the difference between the highest and the second highest Grants(current US$) in El Salvador?
Provide a succinct answer. 1.48e+06. What is the difference between the highest and the second highest Grants(current US$) of Mali?
Provide a succinct answer. 2.19e+07. What is the difference between the highest and the lowest Grants(current US$) in Belize?
Offer a very short reply. 1.62e+06. What is the difference between the highest and the lowest Grants(current US$) in Colombia?
Ensure brevity in your answer.  1.61e+08. What is the difference between the highest and the lowest Grants(current US$) of El Salvador?
Provide a short and direct response. 3.26e+07. What is the difference between the highest and the lowest Grants(current US$) of Mali?
Give a very brief answer. 5.20e+07. 